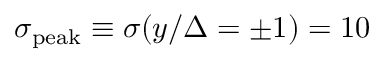Convert formula to latex. <formula><loc_0><loc_0><loc_500><loc_500>\sigma _ { p e a k } \equiv \sigma ( y / \Delta = \pm 1 ) = 1 0</formula> 